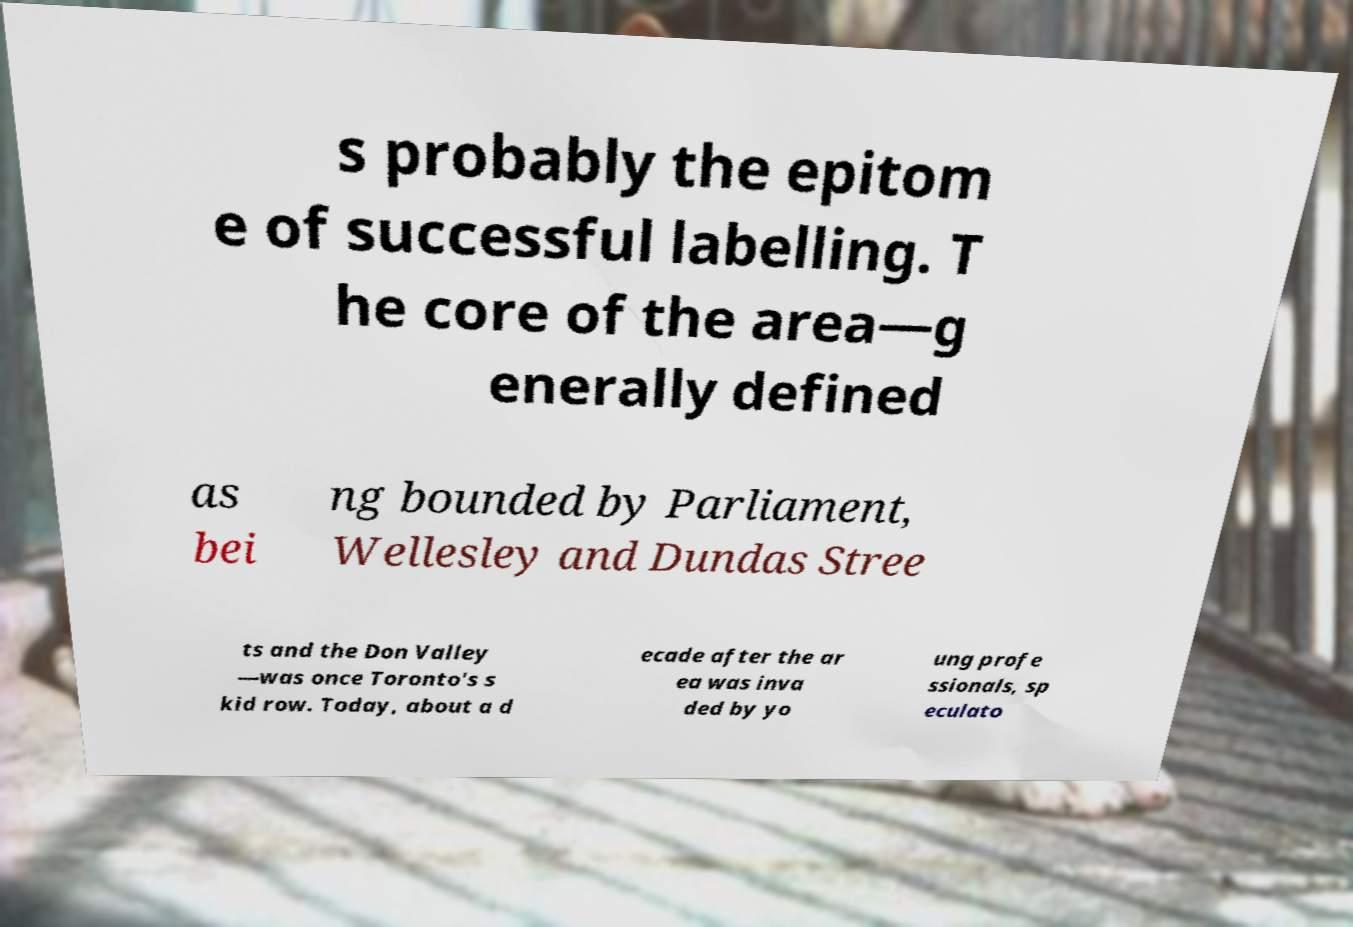Can you accurately transcribe the text from the provided image for me? s probably the epitom e of successful labelling. T he core of the area—g enerally defined as bei ng bounded by Parliament, Wellesley and Dundas Stree ts and the Don Valley —was once Toronto's s kid row. Today, about a d ecade after the ar ea was inva ded by yo ung profe ssionals, sp eculato 